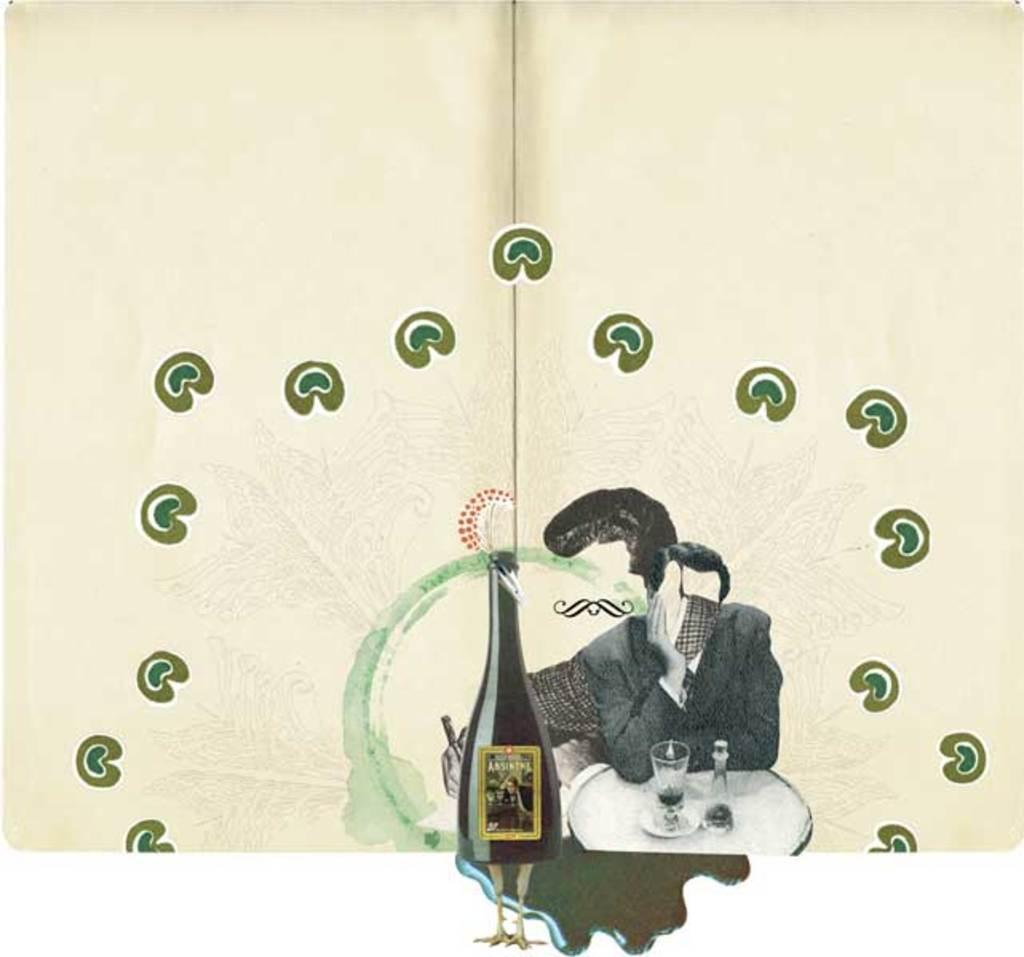What is the main subject of the image? There is a painting in the image. Can you describe the person in the image? There is a man seated in the image. What objects are on the table in the image? There is a glass and a bottle on the table in the image. What type of bottle is on the table? There is a champagne bottle on the table in the image. Can you tell me how many twigs are being held by the goat in the image? There is no goat or twigs present in the image. What is the aunt doing in the image? There is no aunt present in the image. 